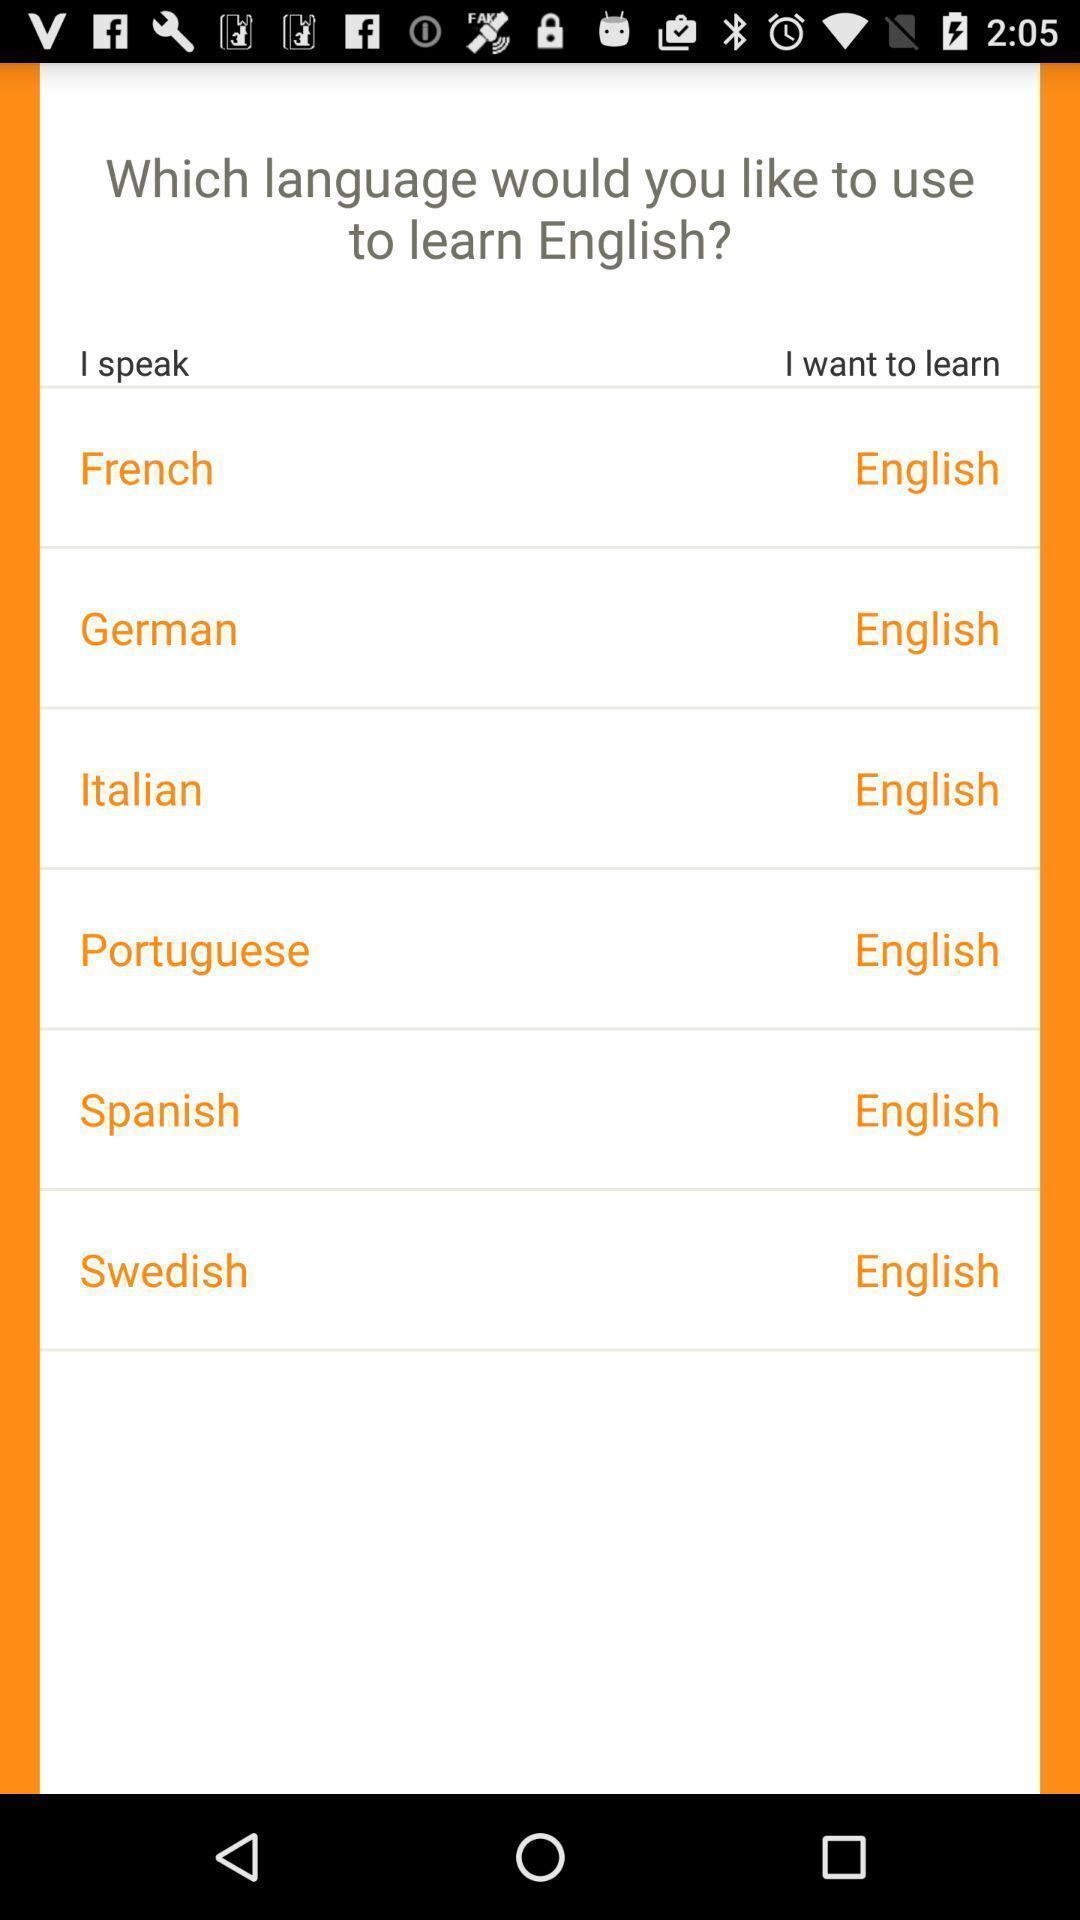Describe the content in this image. Page shows to select language in the language learning app. 